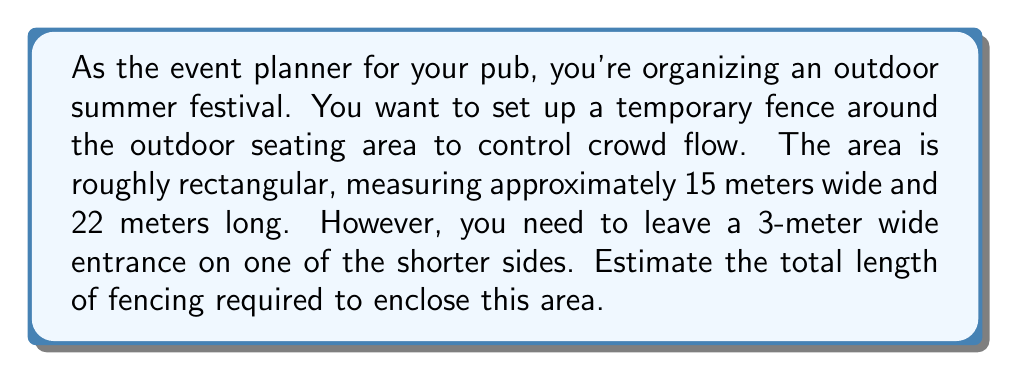Give your solution to this math problem. To solve this problem, we need to calculate the perimeter of the rectangular area and then subtract the width of the entrance. Let's break it down step by step:

1. Calculate the perimeter of the full rectangle:
   Perimeter of a rectangle = 2(length + width)
   $$P = 2(l + w)$$
   $$P = 2(22 + 15) = 2(37) = 74\text{ meters}$$

2. Subtract the width of the entrance:
   The entrance is on one of the shorter sides, which is 3 meters wide.
   $$\text{Fencing required} = 74 - 3 = 71\text{ meters}$$

[asy]
unitsize(0.2cm);
draw((0,0)--(15,0)--(15,22)--(0,22)--cycle);
draw((6,22)--(9,22),blue);
label("22 m", (15.5,11), E);
label("15 m", (7.5,-1), S);
label("3 m", (7.5,23), N);
label("Entrance", (7.5,22.5), N, blue);
[/asy]

This calculation gives us the exact amount of fencing needed. However, as an event planner, it's wise to add a small buffer for any potential miscalculations or adjustments needed on-site. A common practice is to add about 5% extra.

$$\text{Buffer} = 71 \times 0.05 = 3.55\text{ meters}$$

Thus, the final estimate for fencing should be:
$$71 + 3.55 = 74.55\text{ meters}$$

Rounding up to the nearest meter for practical purposes, we get 75 meters.
Answer: 75 meters 